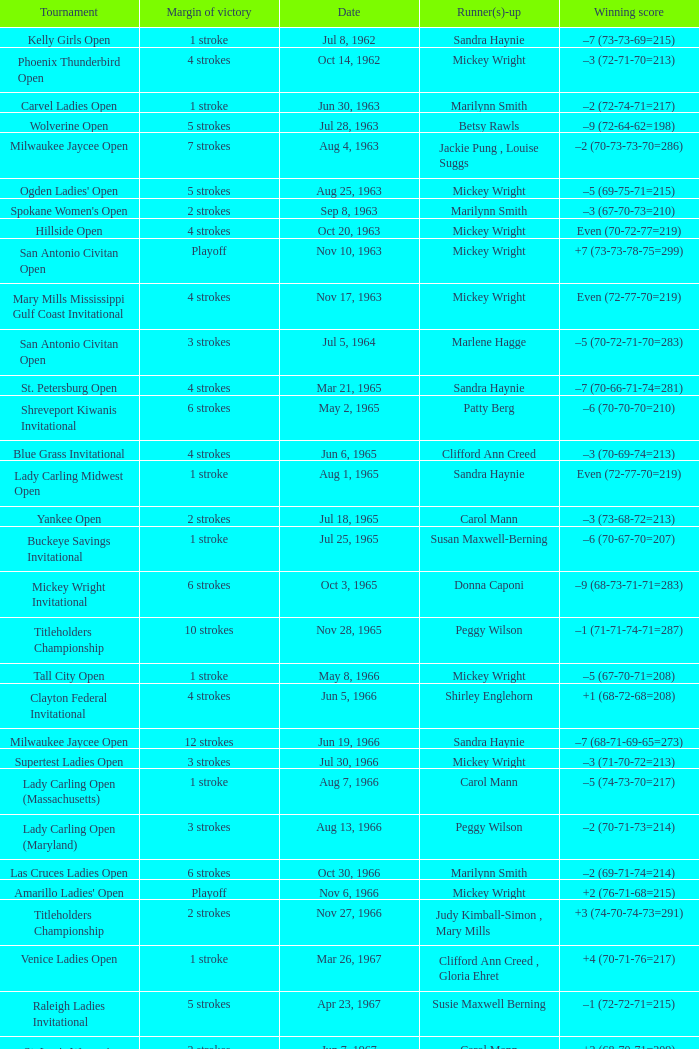What was the margin of victory on Apr 23, 1967? 5 strokes. 